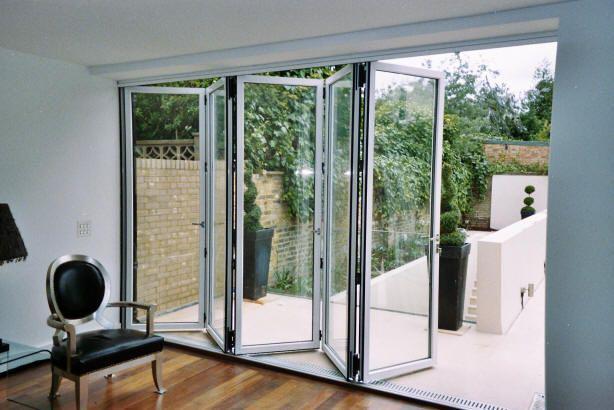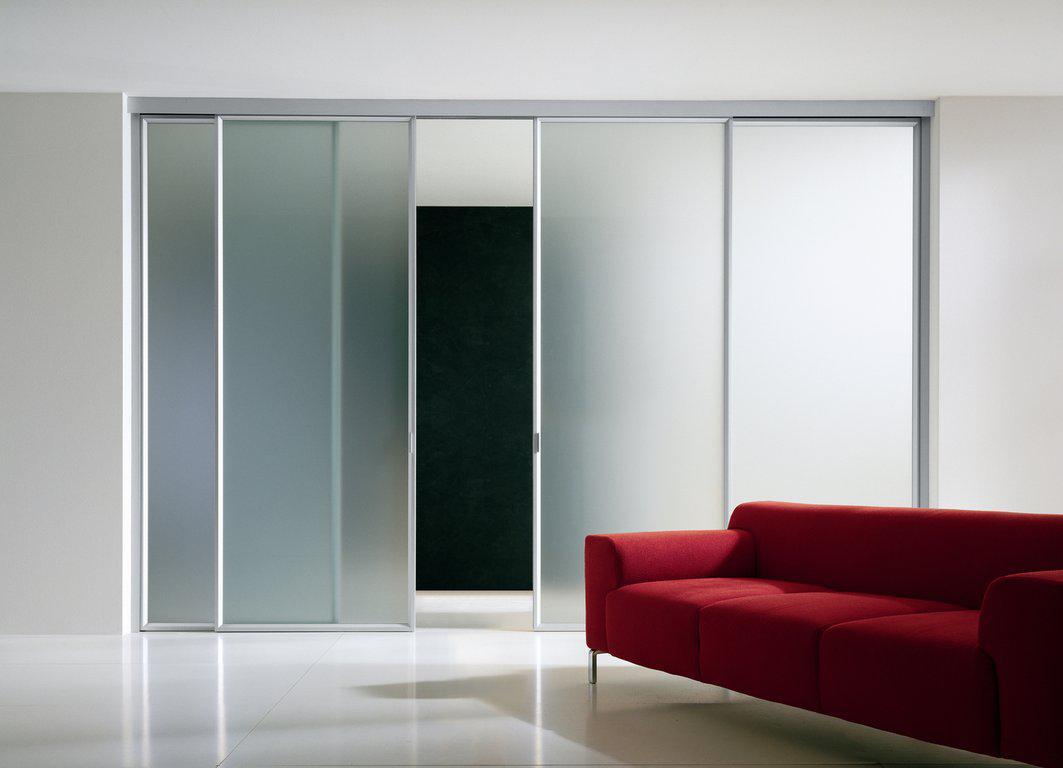The first image is the image on the left, the second image is the image on the right. Considering the images on both sides, is "One of the images has horizontal blinds on the glass doors." valid? Answer yes or no. No. 